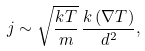Convert formula to latex. <formula><loc_0><loc_0><loc_500><loc_500>j \sim \sqrt { \frac { k T } { m } } \, \frac { k \, ( \nabla T ) } { d ^ { 2 } } ,</formula> 